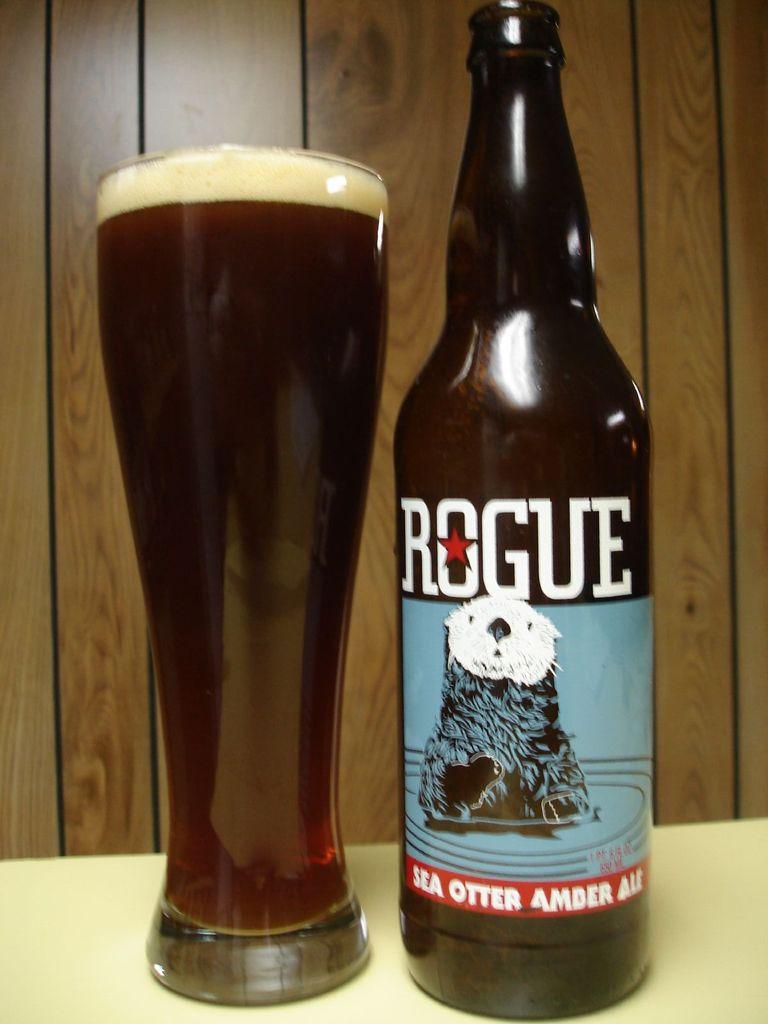To you like beer?
Your answer should be compact. Answering does not require reading text in the image. 